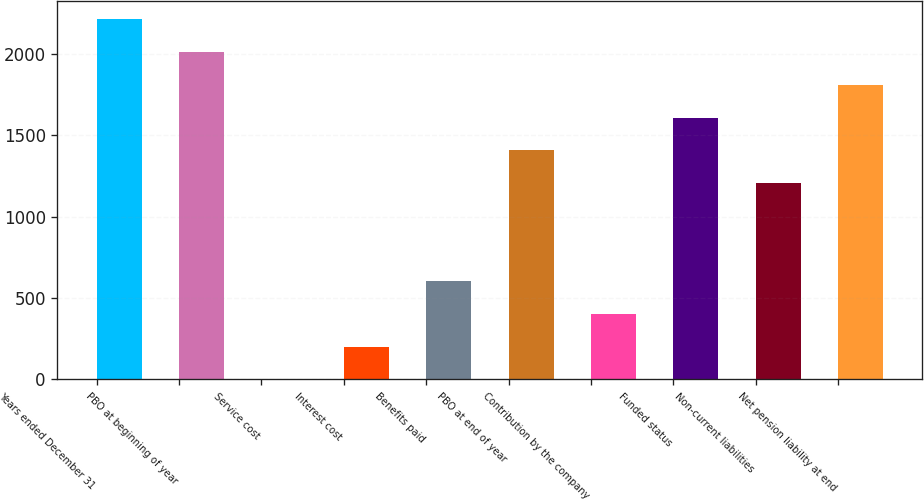Convert chart. <chart><loc_0><loc_0><loc_500><loc_500><bar_chart><fcel>Years ended December 31<fcel>PBO at beginning of year<fcel>Service cost<fcel>Interest cost<fcel>Benefits paid<fcel>PBO at end of year<fcel>Contribution by the company<fcel>Funded status<fcel>Non-current liabilities<fcel>Net pension liability at end<nl><fcel>2210.98<fcel>2010<fcel>0.2<fcel>201.18<fcel>603.14<fcel>1407.06<fcel>402.16<fcel>1608.04<fcel>1206.08<fcel>1809.02<nl></chart> 